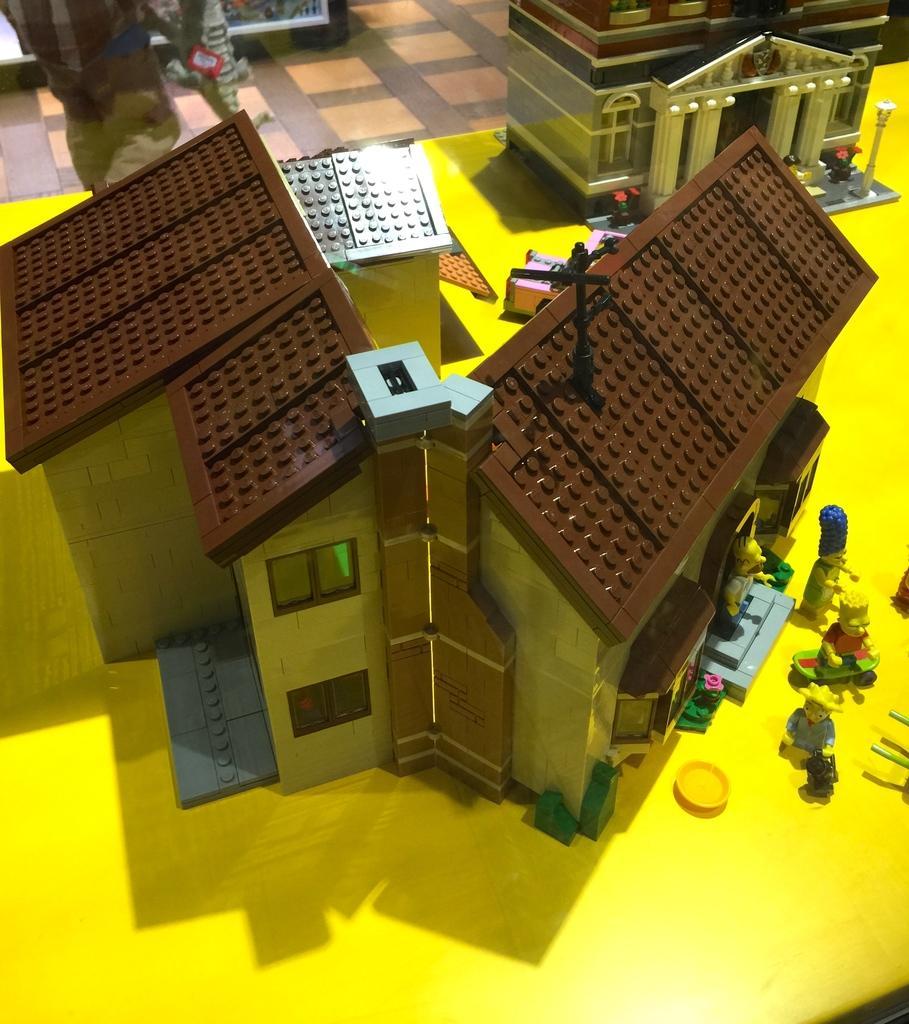How would you summarize this image in a sentence or two? In this image we can see the depiction of a building, houses, people. vehicle, flower pots, light pole, objects and also the path. 